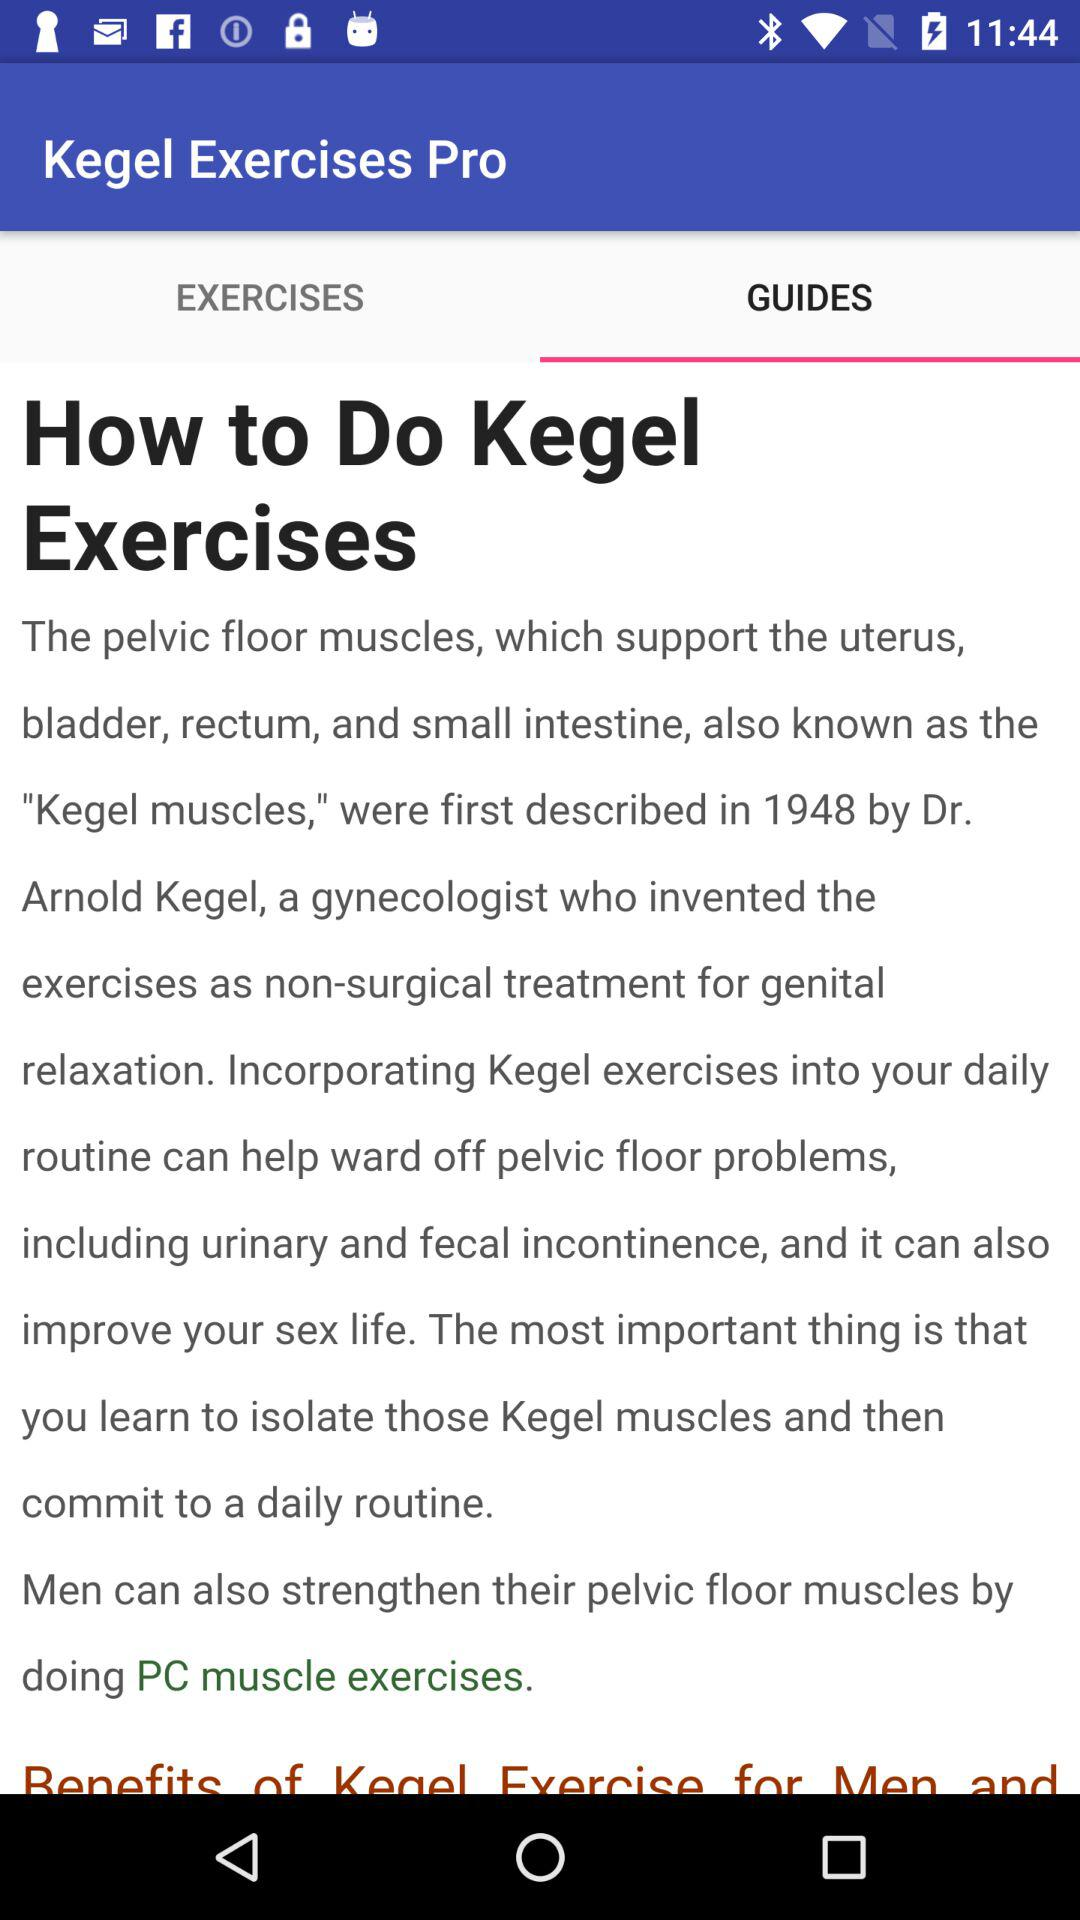What is the name of the application? The application name is Kegel Exercises Pro. 